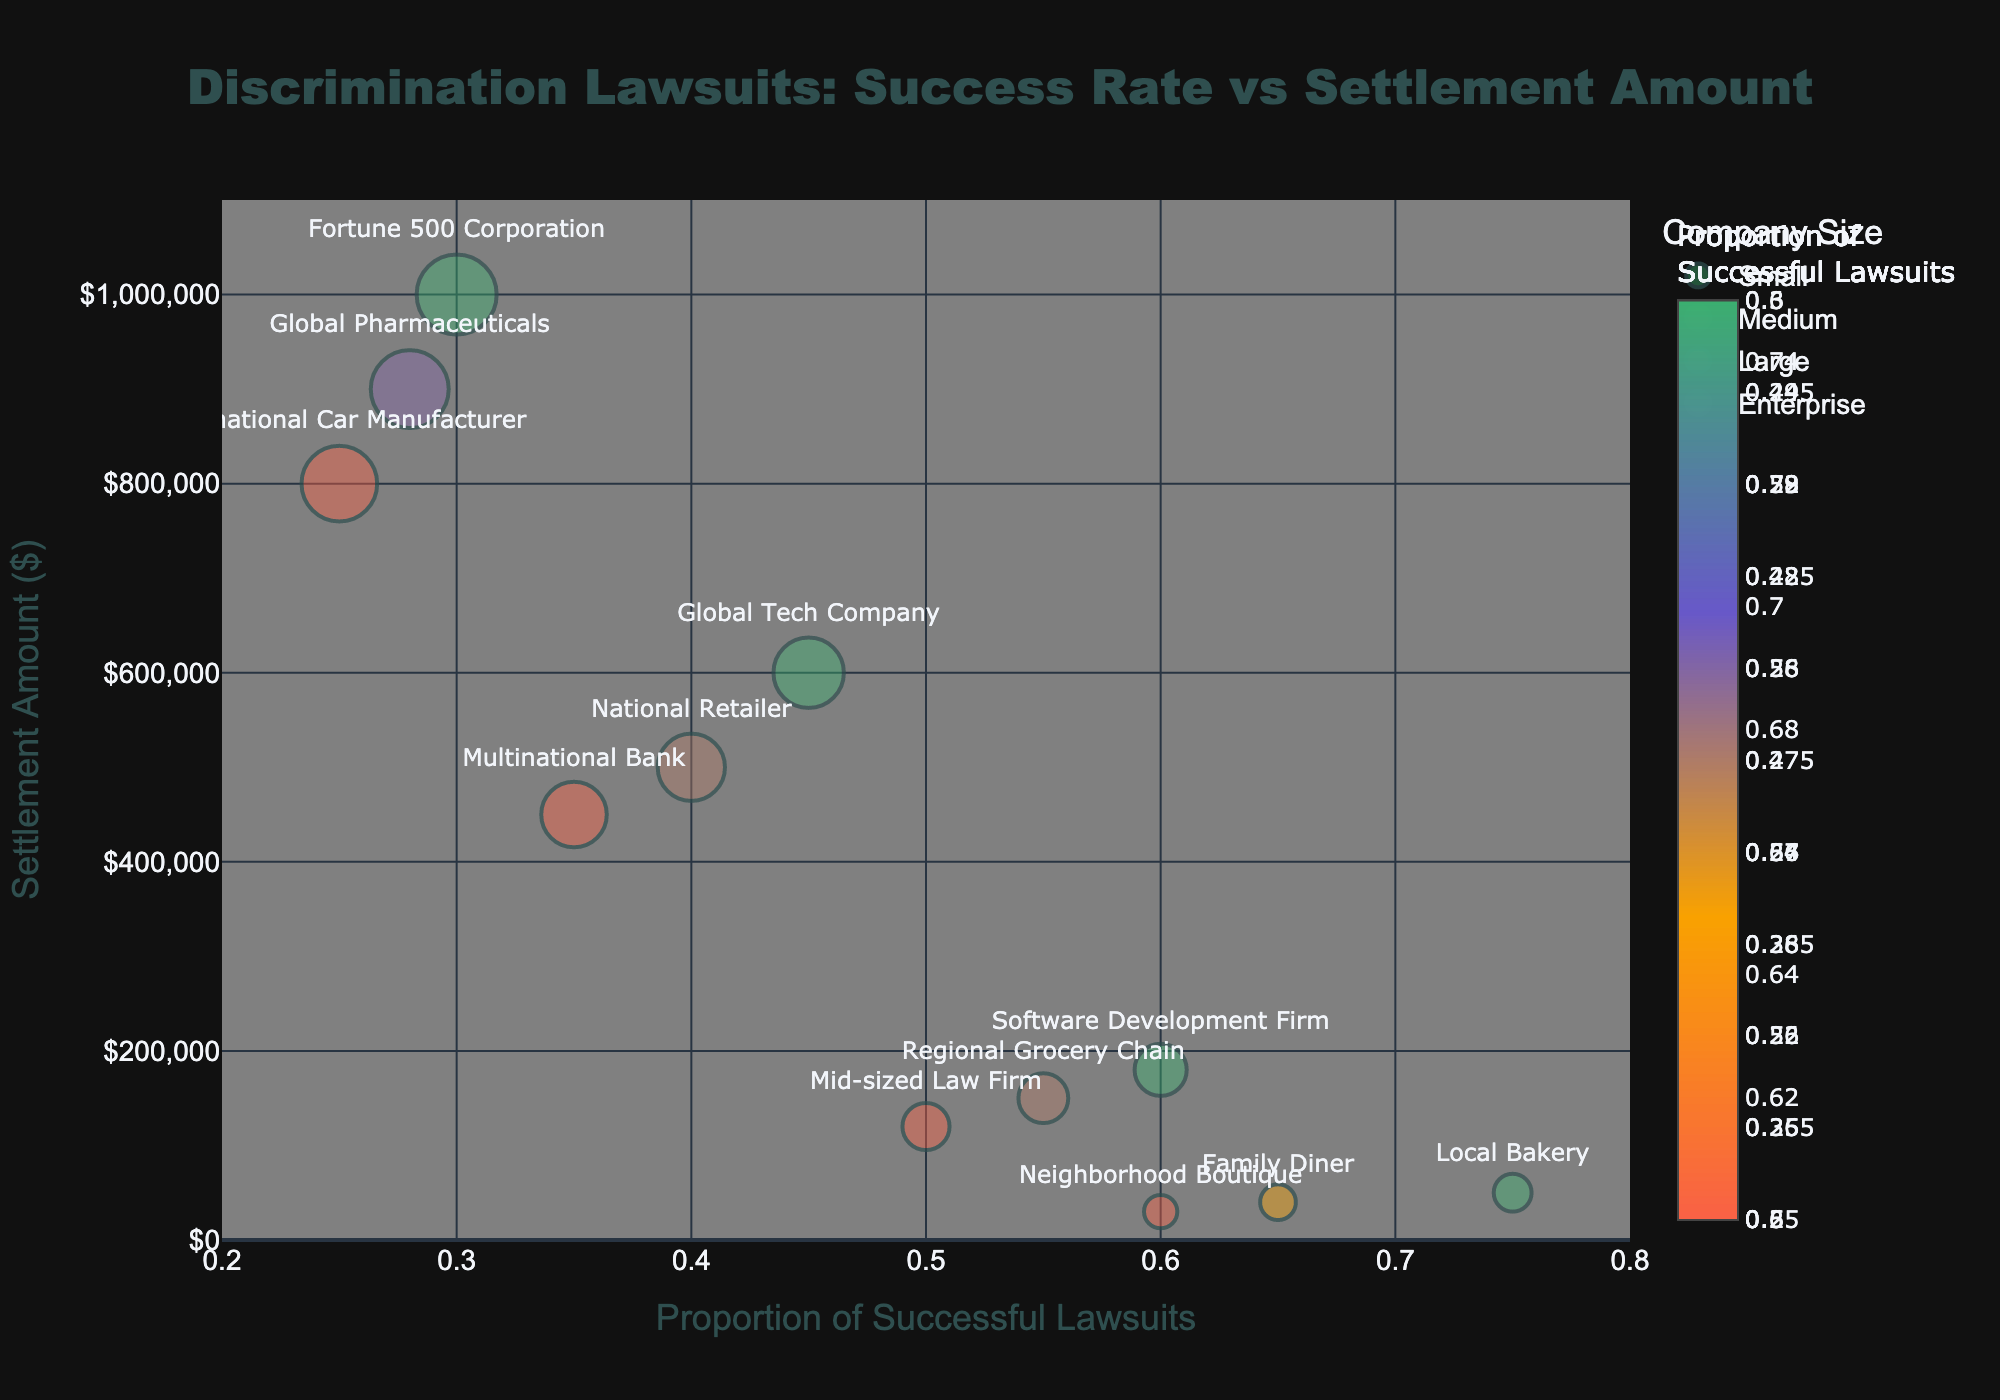How many company sizes are represented in the figure? By counting the unique labels on the figure (Small, Medium, Large, and Enterprise), I can see there are four categories.
Answer: 4 Which company has the highest settlement amount, and what is that amount? By checking the y-axis values and the accompanying text labels, the highest settlement amount corresponds to the "Fortune 500 Corporation" bubble with $1,000,000.
Answer: Fortune 500 Corporation, $1,000,000 Which company size category has the highest proportion of successful discrimination lawsuits on average? By averaging the proportions within each company size category: Small (0.75, 0.60, 0.65 = average 0.67), Medium (0.55, 0.50, 0.60 = average 0.55), Large (0.40, 0.35, 0.45 = average 0.40), Enterprise (0.30, 0.25, 0.28 = average 0.28), it is clear that Small has the highest average proportion.
Answer: Small What is the settlement amount range for Large companies? By finding the minimum and maximum values on the y-axis for the "Large" category, the range is from $450,000 to $600,000.
Answer: $450,000 to $600,000 Which company size category has the lowest rate of successful discrimination lawsuits, and what is that rate? By checking the x-axis values and identifying the lowest proportion of successful lawsuits, "Enterprise" has the lowest rate at 0.25 (for International Car Manufacturer).
Answer: Enterprise, 0.25 Compare the proportion of successful lawsuits and settlement amount for "Family Diner" and "National Retailer." Which company has a higher success rate, and which has a higher settlement amount? "Family Diner" has a success rate of 0.65 and a settlement of $40,000. "National Retailer" has a success rate of 0.40 and a settlement of $500,000. Therefore, "Family Diner" has a higher success rate, while "National Retailer" has a higher settlement amount.
Answer: Family Diner, National Retailer Which company has the smallest bubble, and what does this represent about settlement amount? By visually comparing the sizes of the bubbles, the smallest bubble belongs to "Neighborhood Boutique," indicating it has the smallest settlement amount of $30,000 among the companies.
Answer: Neighborhood Boutique, $30,000 How does the settlement amount correlate with the proportion of successful lawsuits for medium-sized companies? By looking at the three medium-sized companies: Regional Grocery Chain (0.55, $150,000), Mid-sized Law Firm (0.50, $120,000), Software Development Firm (0.60, $180,000), it's observable that there's a positive but weak correlation, meaning higher success rates slightly correspond to higher settlements.
Answer: Positive, weak correlation 